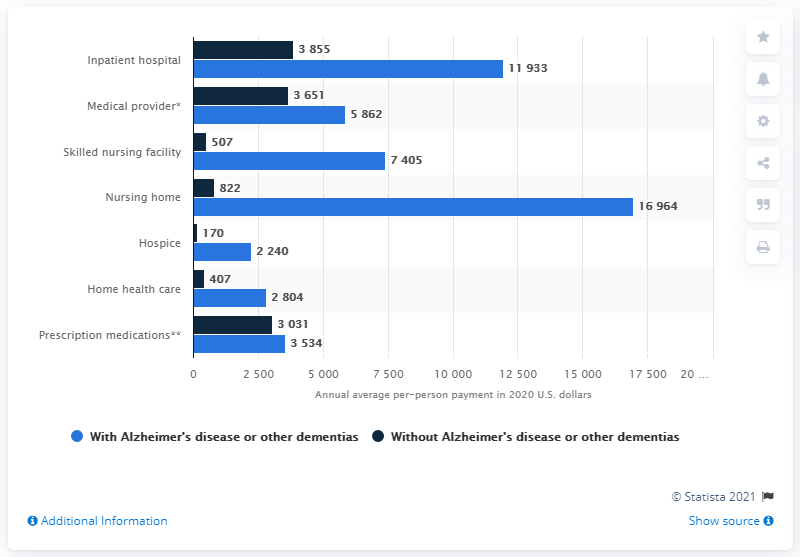Indicate a few pertinent items in this graphic. The average per-beneficiary payment for hospice services was $170 in [year]. 